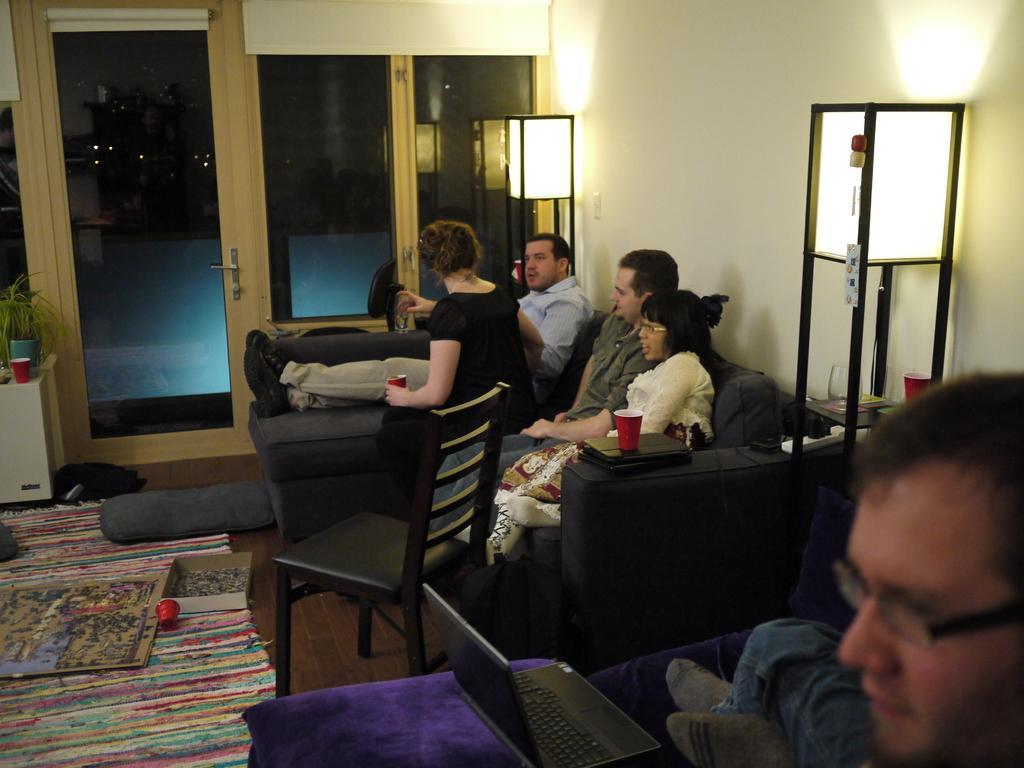Can you describe this image briefly? In the picture we can see inside view of the house with a black color sofa with some people sitting on it and near to them we can see a chair which is also black in color and beside it we can see a floor mat and on it we can see some box and some cardboard on it we can see some painting and near to it we can see a white color table on it we can see a house plant and beside the sofa we can see a table on it we can see a laptop and one person sitting beside it and to the wall we can see a lights with stand and doors with glass and wooden frames. 